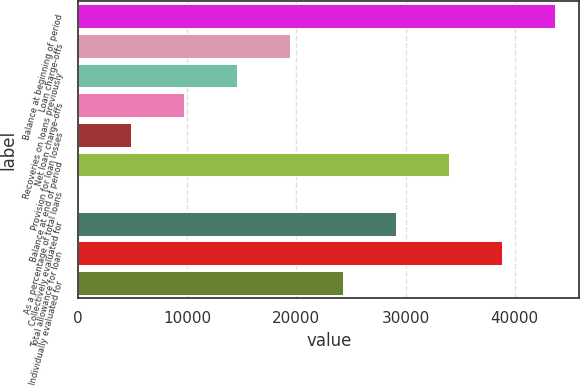Convert chart to OTSL. <chart><loc_0><loc_0><loc_500><loc_500><bar_chart><fcel>Balance at beginning of period<fcel>Loan charge-offs<fcel>Recoveries on loans previously<fcel>Net loan charge-offs<fcel>Provision for loan losses<fcel>Balance at end of period<fcel>As a percentage of total loans<fcel>Collectively evaluated for<fcel>Total allowance for loan<fcel>Individually evaluated for<nl><fcel>43733.8<fcel>19437.9<fcel>14578.8<fcel>9719.58<fcel>4860.4<fcel>34015.5<fcel>1.22<fcel>29156.3<fcel>38874.7<fcel>24297.1<nl></chart> 